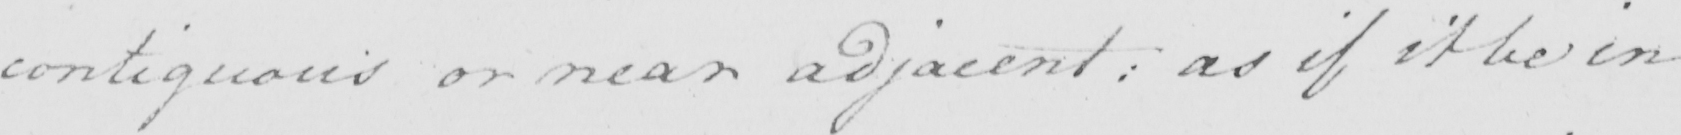Please provide the text content of this handwritten line. contiguous or near adjacent :  as if it be in 